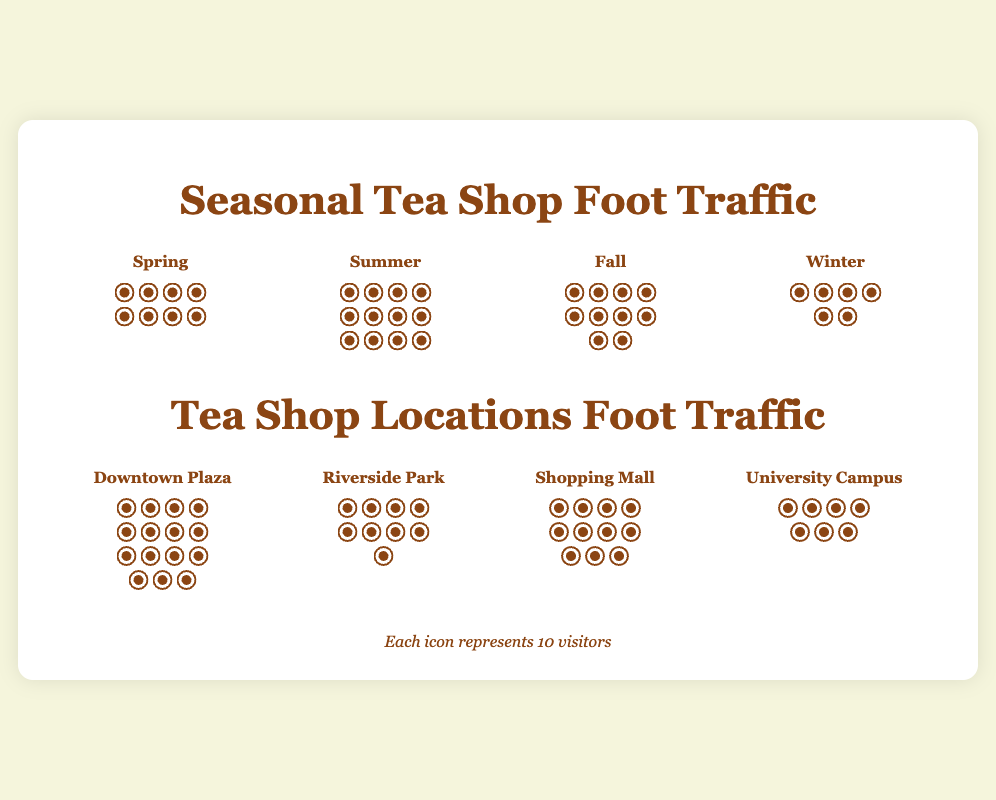What season has the highest foot traffic? The "Summer" column has the most footprint icons, indicating the highest foot traffic during this season.
Answer: Summer How much higher is the foot traffic in Fall compared to Winter? Fall has 10 footprint icons (100 visitors) and Winter has 6 footprint icons (60 visitors). The difference is 100 - 60 = 40 visitors.
Answer: 40 Which location has the least foot traffic? The "University Campus" column has the fewest footprint icons, indicating the lowest foot traffic among the locations.
Answer: University Campus What is the combined foot traffic for Spring and Winter? Spring has 8 footprint icons (80 visitors) and Winter has 6 footprint icons (60 visitors). The combined foot traffic is 80 + 60 = 140 visitors.
Answer: 140 How many more visitors does Downtown Plaza have compared to Riverside Park? Downtown Plaza has 15 footprint icons (150 visitors) and Riverside Park has 9 footprint icons (90 visitors). The difference is 150 - 90 = 60 visitors.
Answer: 60 Which season has the second highest foot traffic? The "Fall" column has the second most footprint icons, indicating the second highest foot traffic.
Answer: Fall Is the foot traffic higher in Summer or at the Shopping Mall? Summer has 12 footprint icons (120 visitors) and the Shopping Mall has 11 footprint icons (110 visitors). Thus, the foot traffic is higher in Summer.
Answer: Summer What is the average foot traffic across the four seasons? Summing the foot traffic: Spring (80) + Summer (120) + Fall (100) + Winter (60) = 360 visitors. There are 4 seasons, so the average is 360 / 4 = 90 visitors.
Answer: 90 Which location has approximately the same foot traffic as Fall? The "Shopping Mall" column has 11 footprint icons (110 visitors), approximately equal to Fall's 10 footprint icons (100 visitors).
Answer: Shopping Mall 